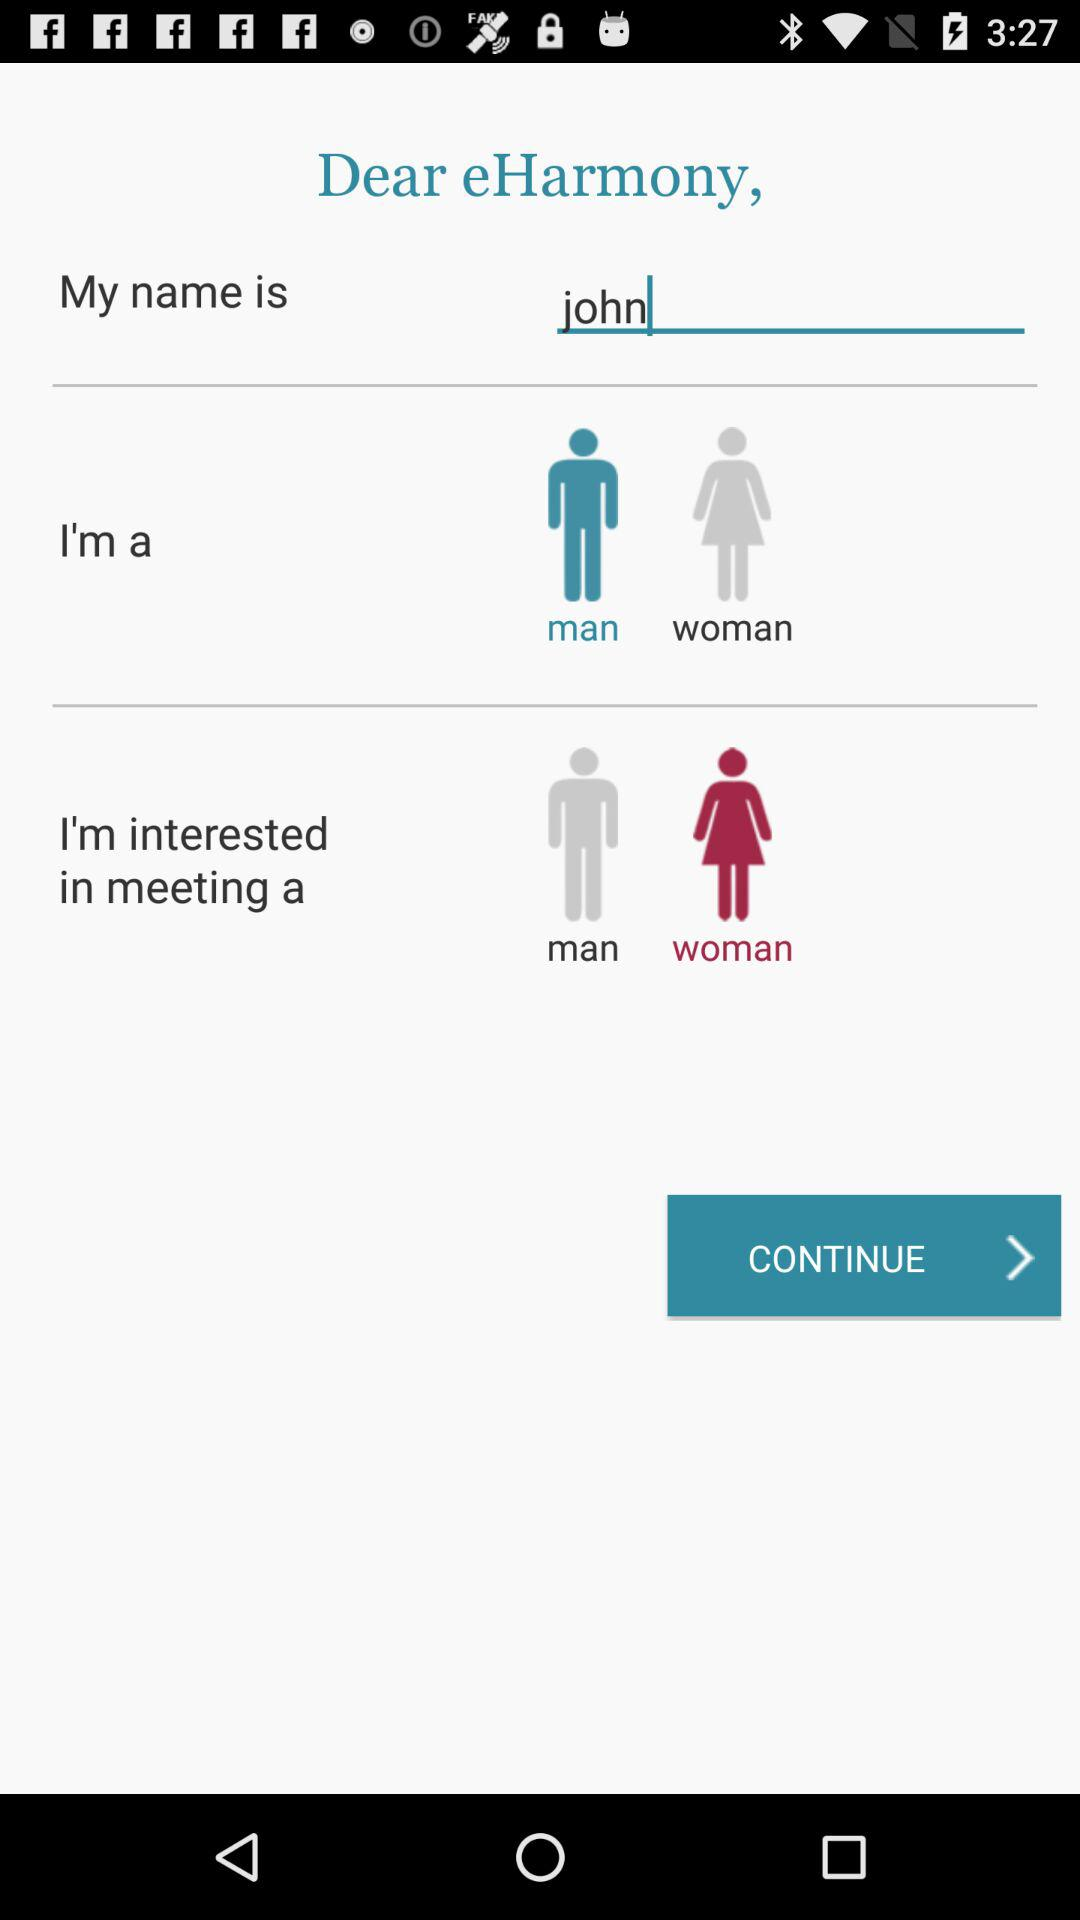What is the option of Gender?
When the provided information is insufficient, respond with <no answer>. <no answer> 